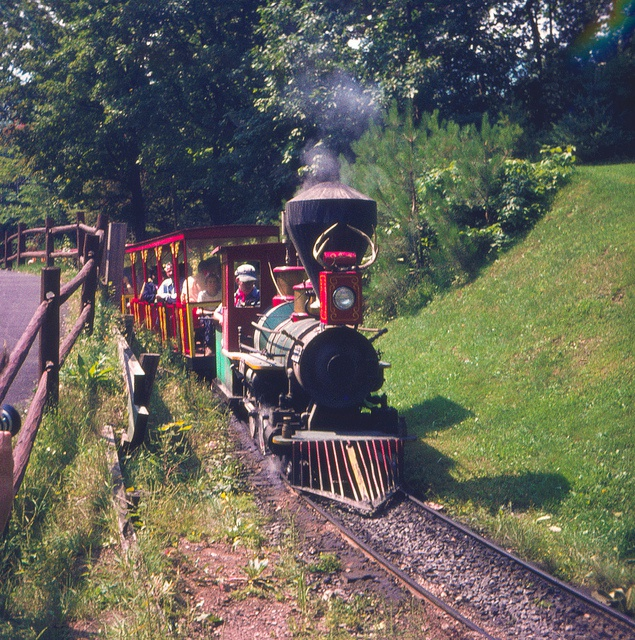Describe the objects in this image and their specific colors. I can see train in teal, black, gray, and purple tones, people in teal, navy, white, gray, and purple tones, people in teal, gray, purple, and white tones, people in teal, white, salmon, gray, and black tones, and people in blue, white, purple, gray, and lightpink tones in this image. 